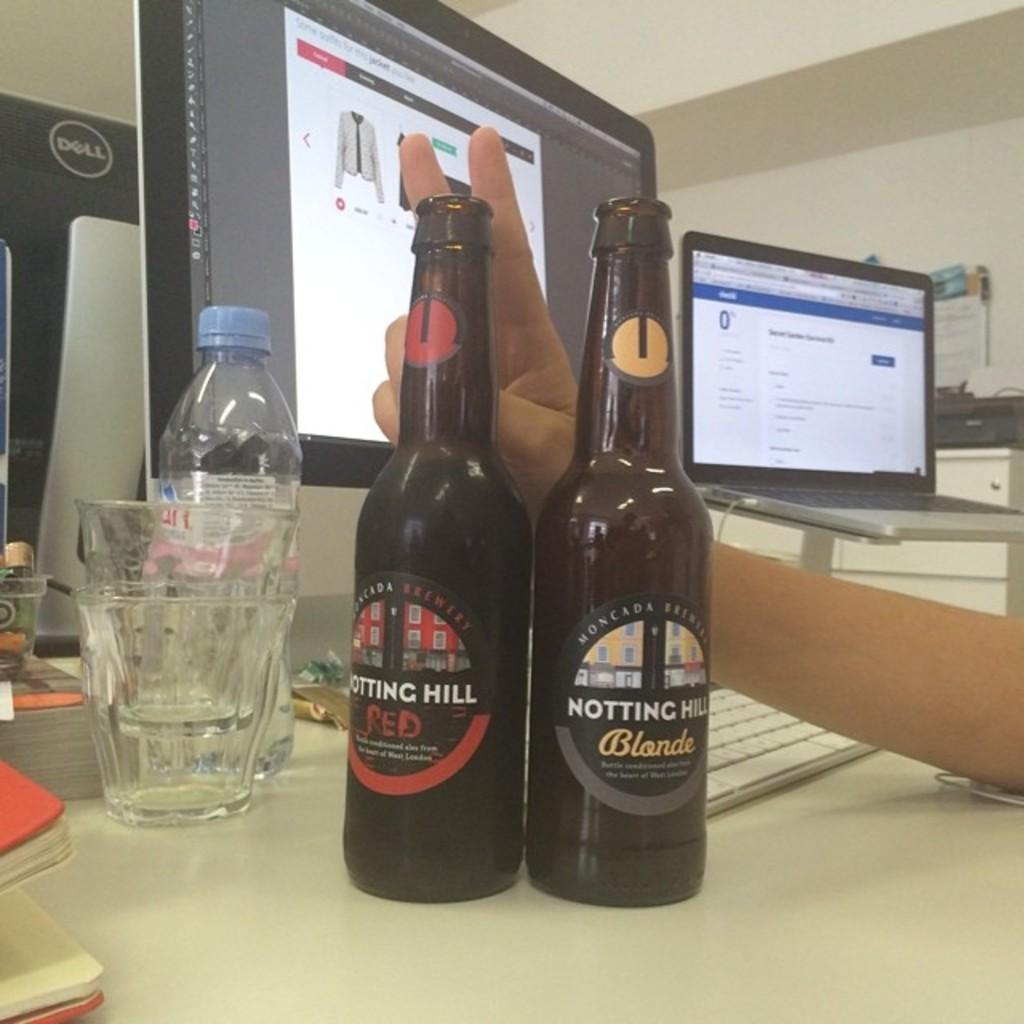<image>
Present a compact description of the photo's key features. A bottle of Notting Hill Blonde and a bottle of Notting Hill Red. 